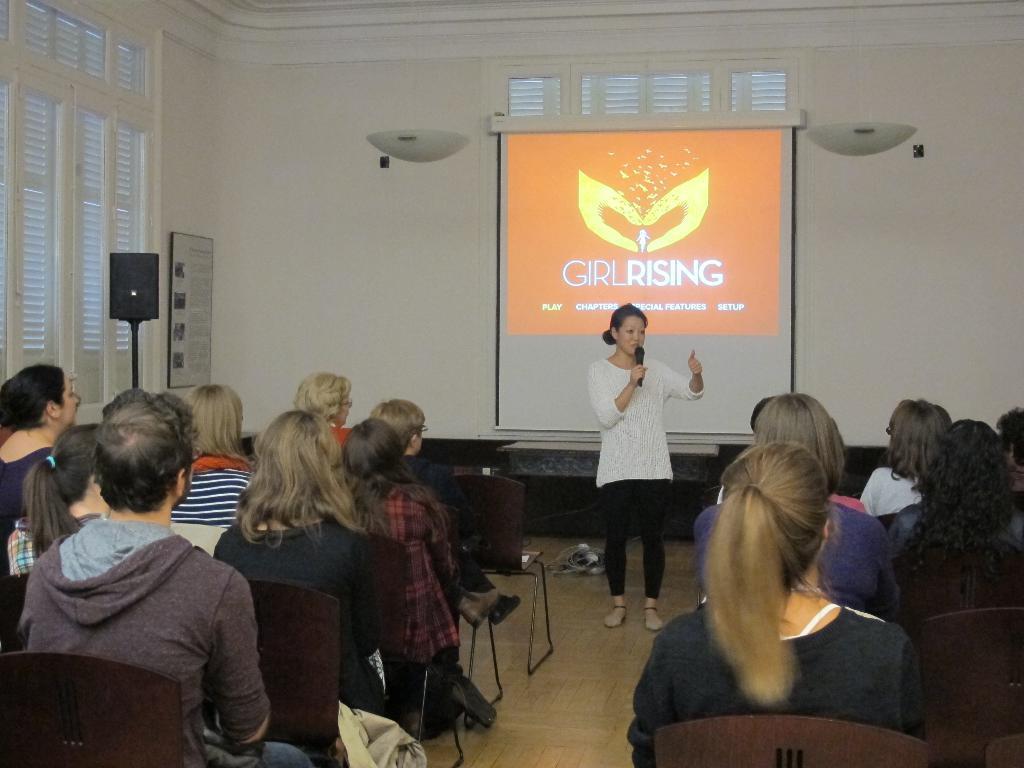In one or two sentences, can you explain what this image depicts? This image is clicked inside a room. There are windows on the left side. There is a screen in the middle. There is a person standing and talking something in the middle. There are so many persons in the middle, who are sitting on chairs. 